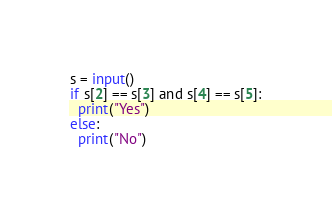Convert code to text. <code><loc_0><loc_0><loc_500><loc_500><_Python_>s = input()
if s[2] == s[3] and s[4] == s[5]:
  print("Yes")
else:
  print("No")</code> 